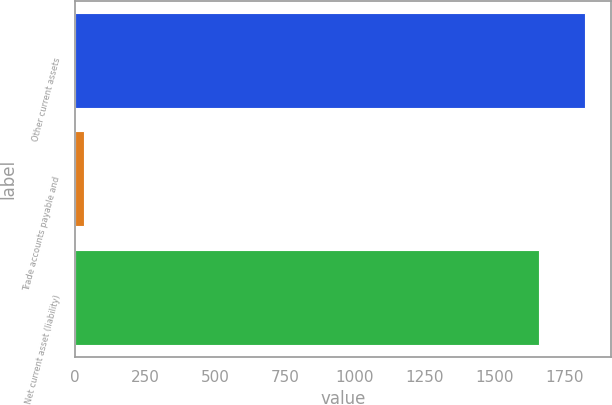Convert chart. <chart><loc_0><loc_0><loc_500><loc_500><bar_chart><fcel>Other current assets<fcel>Trade accounts payable and<fcel>Net current asset (liability)<nl><fcel>1823.8<fcel>32<fcel>1658<nl></chart> 